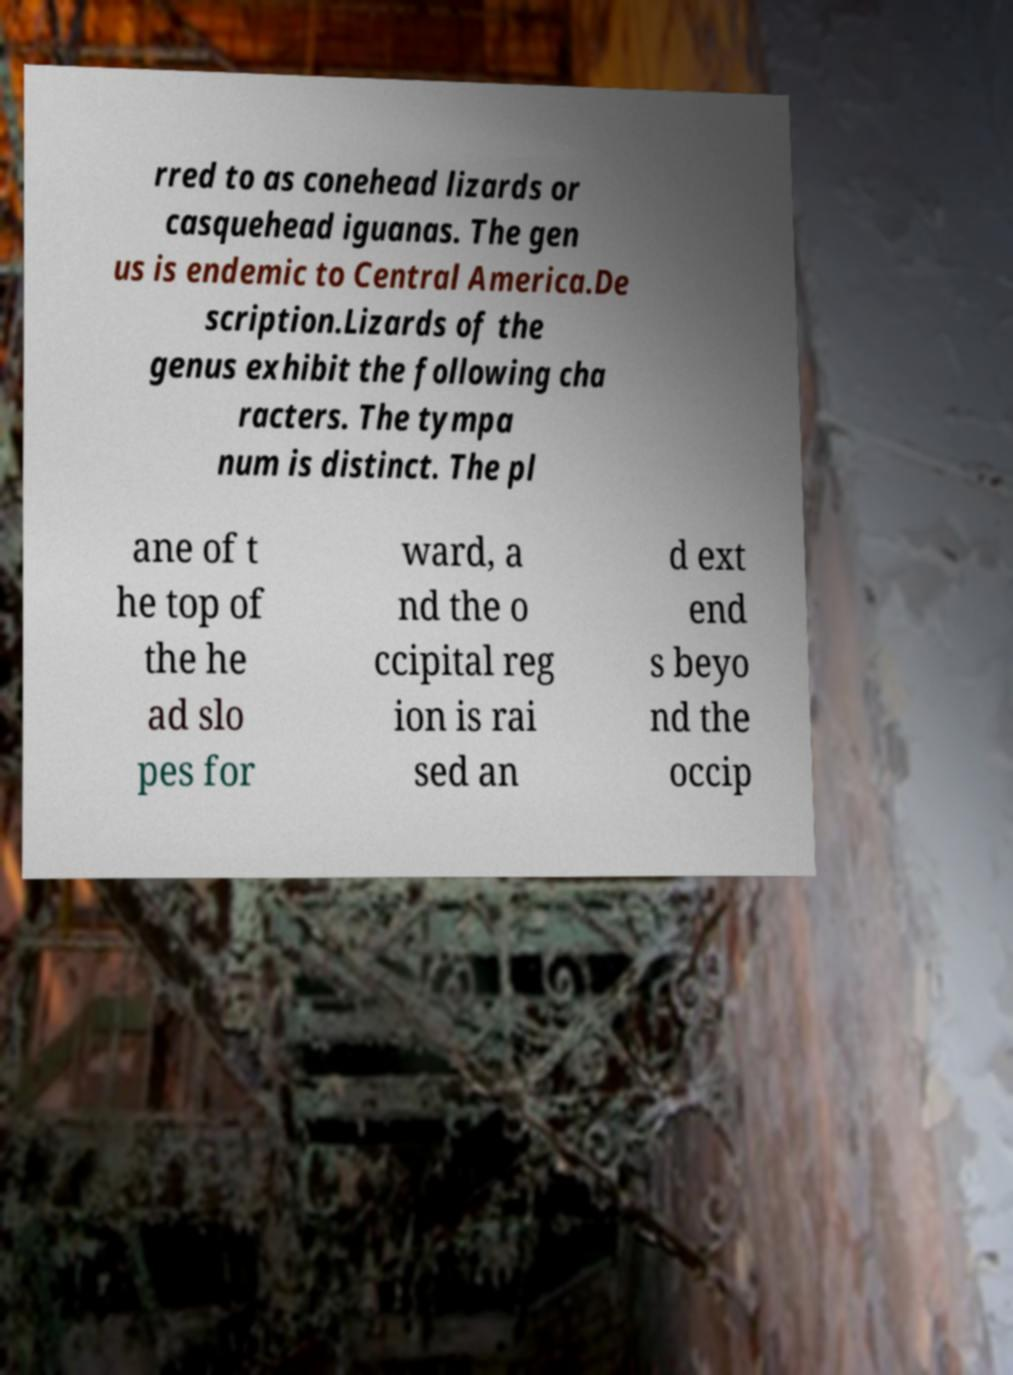There's text embedded in this image that I need extracted. Can you transcribe it verbatim? rred to as conehead lizards or casquehead iguanas. The gen us is endemic to Central America.De scription.Lizards of the genus exhibit the following cha racters. The tympa num is distinct. The pl ane of t he top of the he ad slo pes for ward, a nd the o ccipital reg ion is rai sed an d ext end s beyo nd the occip 